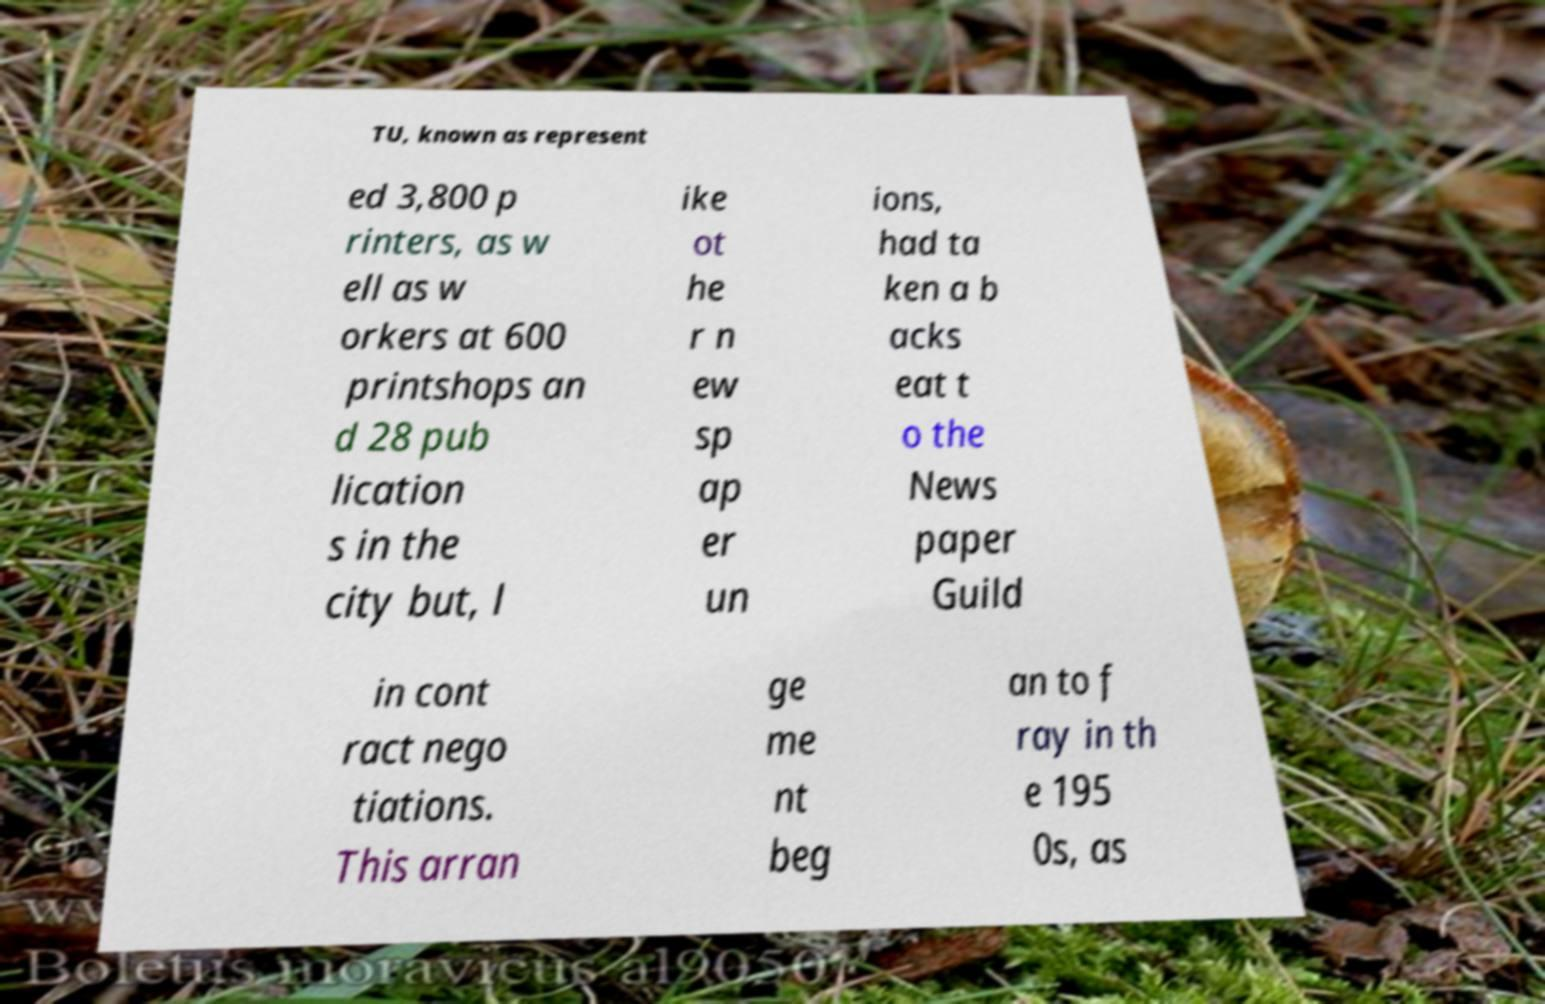For documentation purposes, I need the text within this image transcribed. Could you provide that? TU, known as represent ed 3,800 p rinters, as w ell as w orkers at 600 printshops an d 28 pub lication s in the city but, l ike ot he r n ew sp ap er un ions, had ta ken a b acks eat t o the News paper Guild in cont ract nego tiations. This arran ge me nt beg an to f ray in th e 195 0s, as 